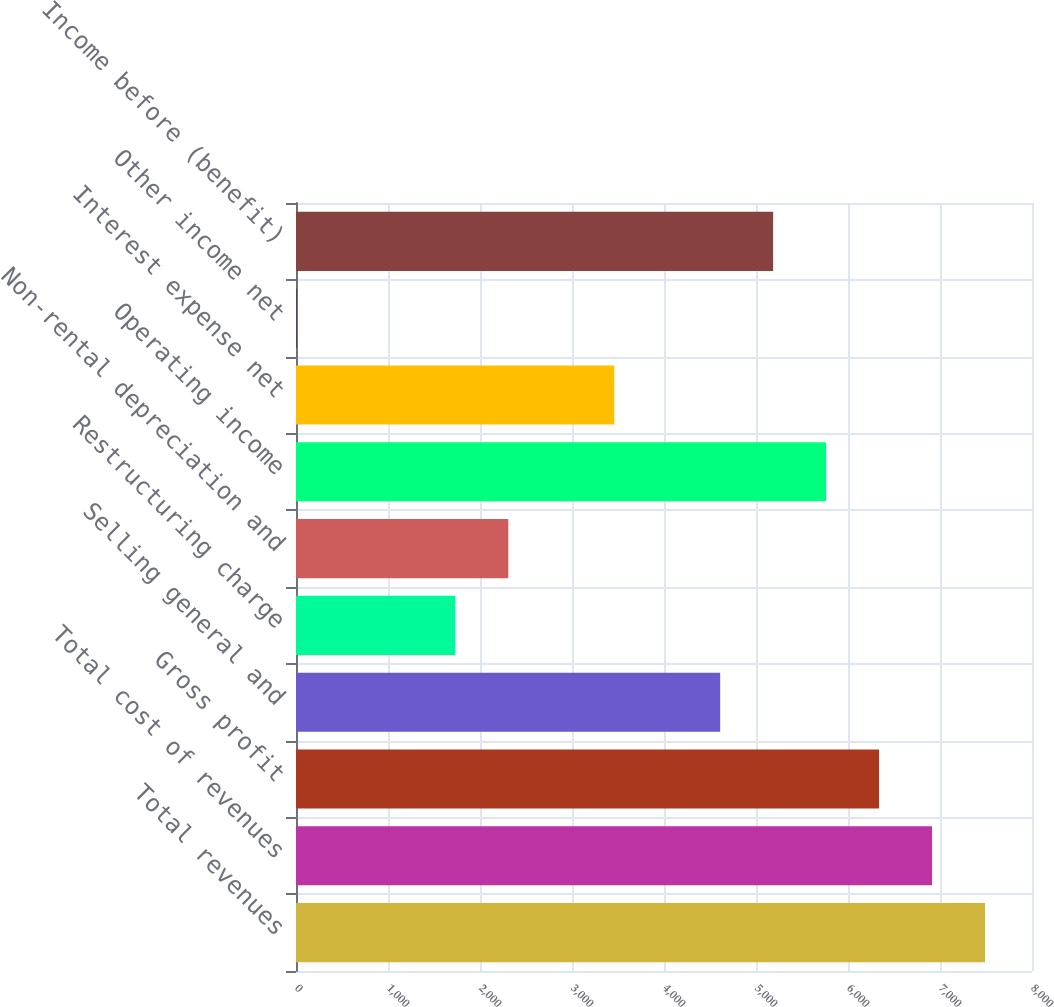Convert chart. <chart><loc_0><loc_0><loc_500><loc_500><bar_chart><fcel>Total revenues<fcel>Total cost of revenues<fcel>Gross profit<fcel>Selling general and<fcel>Restructuring charge<fcel>Non-rental depreciation and<fcel>Operating income<fcel>Interest expense net<fcel>Other income net<fcel>Income before (benefit)<nl><fcel>7489.1<fcel>6913.4<fcel>6337.7<fcel>4610.6<fcel>1732.1<fcel>2307.8<fcel>5762<fcel>3459.2<fcel>5<fcel>5186.3<nl></chart> 